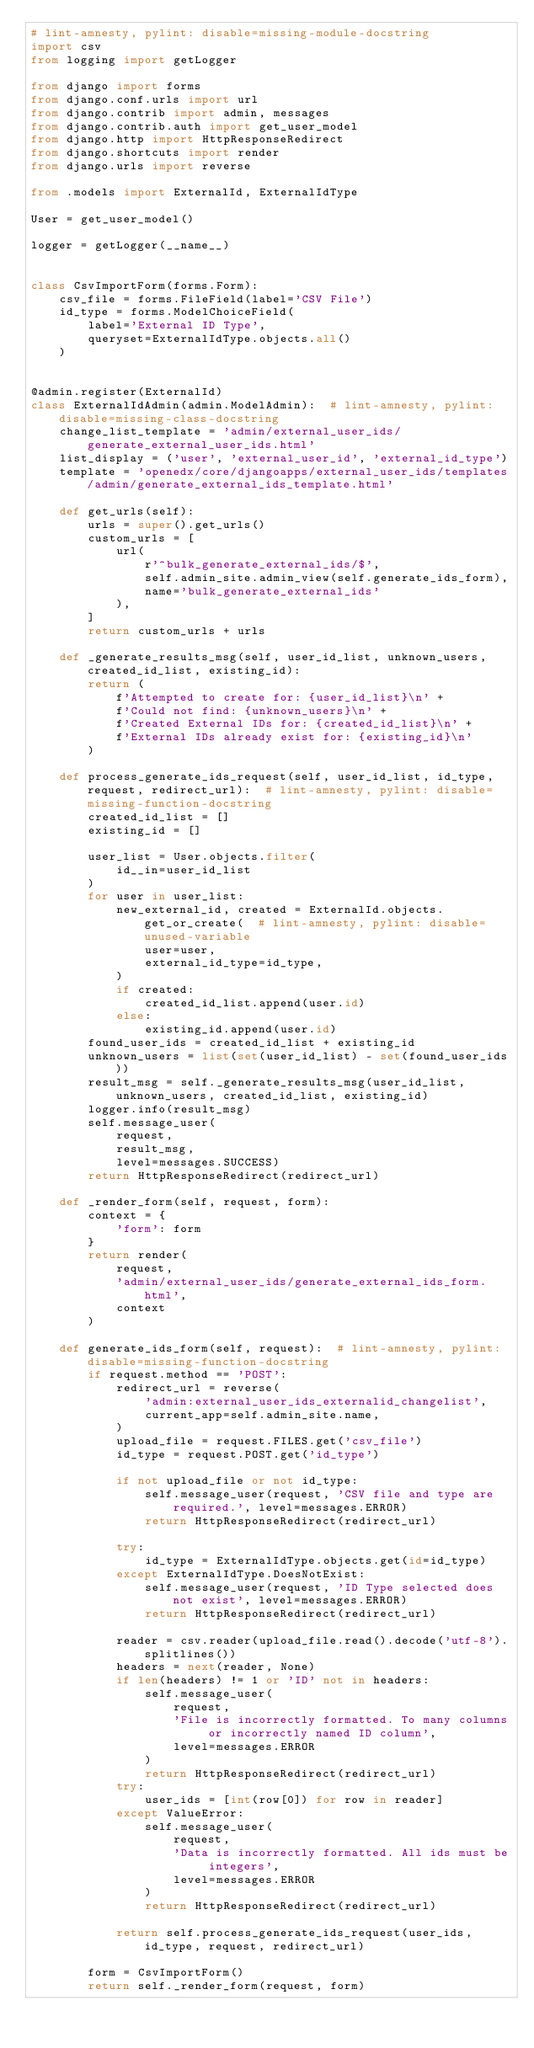<code> <loc_0><loc_0><loc_500><loc_500><_Python_># lint-amnesty, pylint: disable=missing-module-docstring
import csv
from logging import getLogger

from django import forms
from django.conf.urls import url
from django.contrib import admin, messages
from django.contrib.auth import get_user_model
from django.http import HttpResponseRedirect
from django.shortcuts import render
from django.urls import reverse

from .models import ExternalId, ExternalIdType

User = get_user_model()

logger = getLogger(__name__)


class CsvImportForm(forms.Form):
    csv_file = forms.FileField(label='CSV File')
    id_type = forms.ModelChoiceField(
        label='External ID Type',
        queryset=ExternalIdType.objects.all()
    )


@admin.register(ExternalId)
class ExternalIdAdmin(admin.ModelAdmin):  # lint-amnesty, pylint: disable=missing-class-docstring
    change_list_template = 'admin/external_user_ids/generate_external_user_ids.html'
    list_display = ('user', 'external_user_id', 'external_id_type')
    template = 'openedx/core/djangoapps/external_user_ids/templates/admin/generate_external_ids_template.html'

    def get_urls(self):
        urls = super().get_urls()
        custom_urls = [
            url(
                r'^bulk_generate_external_ids/$',
                self.admin_site.admin_view(self.generate_ids_form),
                name='bulk_generate_external_ids'
            ),
        ]
        return custom_urls + urls

    def _generate_results_msg(self, user_id_list, unknown_users, created_id_list, existing_id):
        return (
            f'Attempted to create for: {user_id_list}\n' +
            f'Could not find: {unknown_users}\n' +
            f'Created External IDs for: {created_id_list}\n' +
            f'External IDs already exist for: {existing_id}\n'
        )

    def process_generate_ids_request(self, user_id_list, id_type, request, redirect_url):  # lint-amnesty, pylint: disable=missing-function-docstring
        created_id_list = []
        existing_id = []

        user_list = User.objects.filter(
            id__in=user_id_list
        )
        for user in user_list:
            new_external_id, created = ExternalId.objects.get_or_create(  # lint-amnesty, pylint: disable=unused-variable
                user=user,
                external_id_type=id_type,
            )
            if created:
                created_id_list.append(user.id)
            else:
                existing_id.append(user.id)
        found_user_ids = created_id_list + existing_id
        unknown_users = list(set(user_id_list) - set(found_user_ids))
        result_msg = self._generate_results_msg(user_id_list, unknown_users, created_id_list, existing_id)
        logger.info(result_msg)
        self.message_user(
            request,
            result_msg,
            level=messages.SUCCESS)
        return HttpResponseRedirect(redirect_url)

    def _render_form(self, request, form):
        context = {
            'form': form
        }
        return render(
            request,
            'admin/external_user_ids/generate_external_ids_form.html',
            context
        )

    def generate_ids_form(self, request):  # lint-amnesty, pylint: disable=missing-function-docstring
        if request.method == 'POST':
            redirect_url = reverse(
                'admin:external_user_ids_externalid_changelist',
                current_app=self.admin_site.name,
            )
            upload_file = request.FILES.get('csv_file')
            id_type = request.POST.get('id_type')

            if not upload_file or not id_type:
                self.message_user(request, 'CSV file and type are required.', level=messages.ERROR)
                return HttpResponseRedirect(redirect_url)

            try:
                id_type = ExternalIdType.objects.get(id=id_type)
            except ExternalIdType.DoesNotExist:
                self.message_user(request, 'ID Type selected does not exist', level=messages.ERROR)
                return HttpResponseRedirect(redirect_url)

            reader = csv.reader(upload_file.read().decode('utf-8').splitlines())
            headers = next(reader, None)
            if len(headers) != 1 or 'ID' not in headers:
                self.message_user(
                    request,
                    'File is incorrectly formatted. To many columns or incorrectly named ID column',
                    level=messages.ERROR
                )
                return HttpResponseRedirect(redirect_url)
            try:
                user_ids = [int(row[0]) for row in reader]
            except ValueError:
                self.message_user(
                    request,
                    'Data is incorrectly formatted. All ids must be integers',
                    level=messages.ERROR
                )
                return HttpResponseRedirect(redirect_url)

            return self.process_generate_ids_request(user_ids, id_type, request, redirect_url)

        form = CsvImportForm()
        return self._render_form(request, form)
</code> 